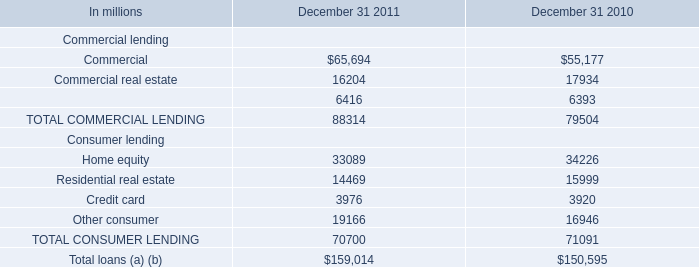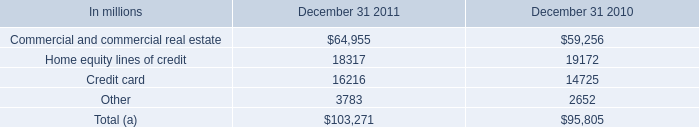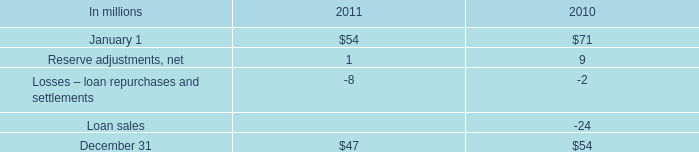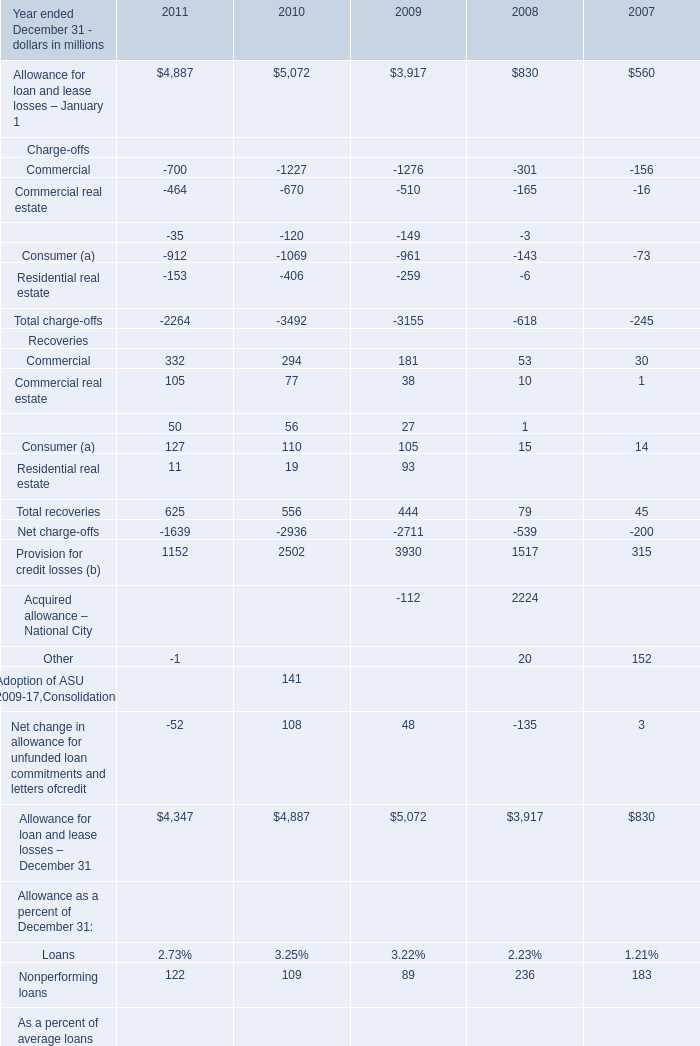What is the growth rate of Total recoveries between Year 2009 ended December 31 and Year 2010 ended December 31? 
Computations: ((444 - 79) / 79)
Answer: 4.62025. 